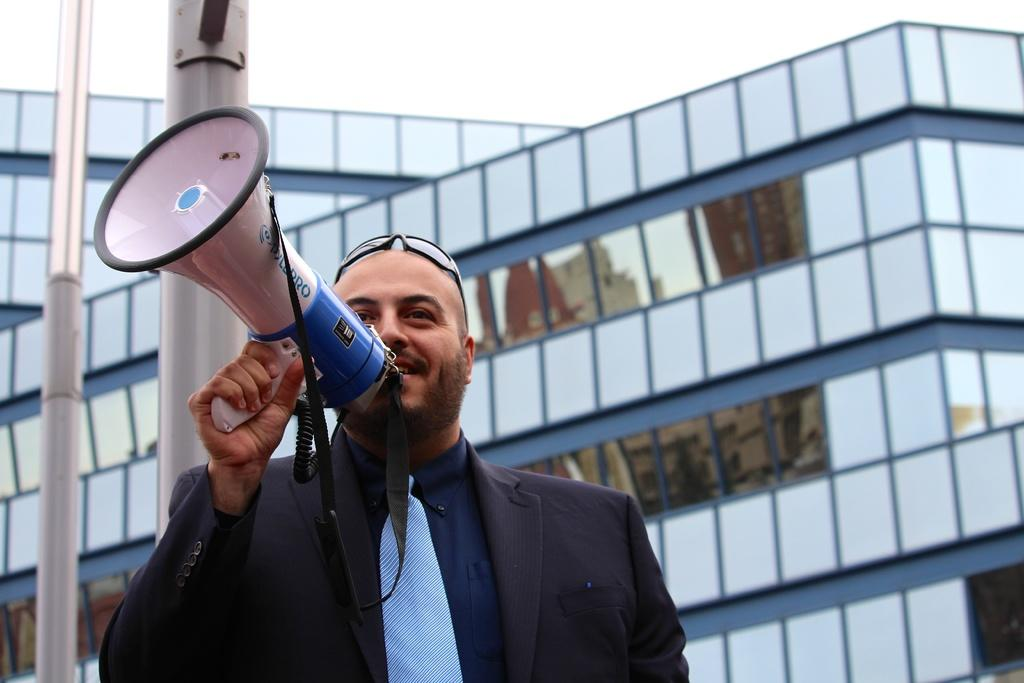What is the person in the image holding? There is a person holding an object in the image. What can be seen in the distance behind the person? There are buildings, poles, and other objects in the background of the image. What is visible at the top of the image? The sky is visible at the top of the image. What type of card is being used to build the tin structure on the stone platform in the image? There is no card, tin, or stone structure present in the image. 